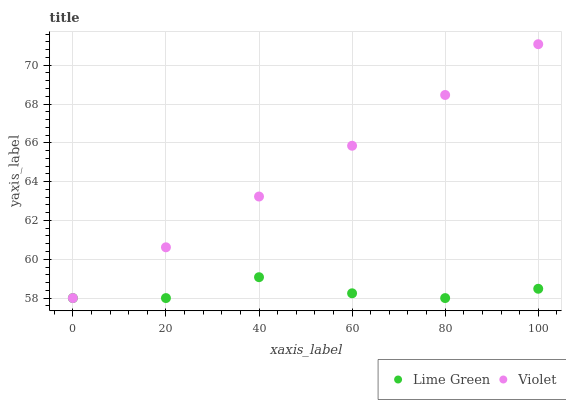Does Lime Green have the minimum area under the curve?
Answer yes or no. Yes. Does Violet have the maximum area under the curve?
Answer yes or no. Yes. Does Violet have the minimum area under the curve?
Answer yes or no. No. Is Violet the smoothest?
Answer yes or no. Yes. Is Lime Green the roughest?
Answer yes or no. Yes. Is Violet the roughest?
Answer yes or no. No. Does Lime Green have the lowest value?
Answer yes or no. Yes. Does Violet have the highest value?
Answer yes or no. Yes. Does Lime Green intersect Violet?
Answer yes or no. Yes. Is Lime Green less than Violet?
Answer yes or no. No. Is Lime Green greater than Violet?
Answer yes or no. No. 